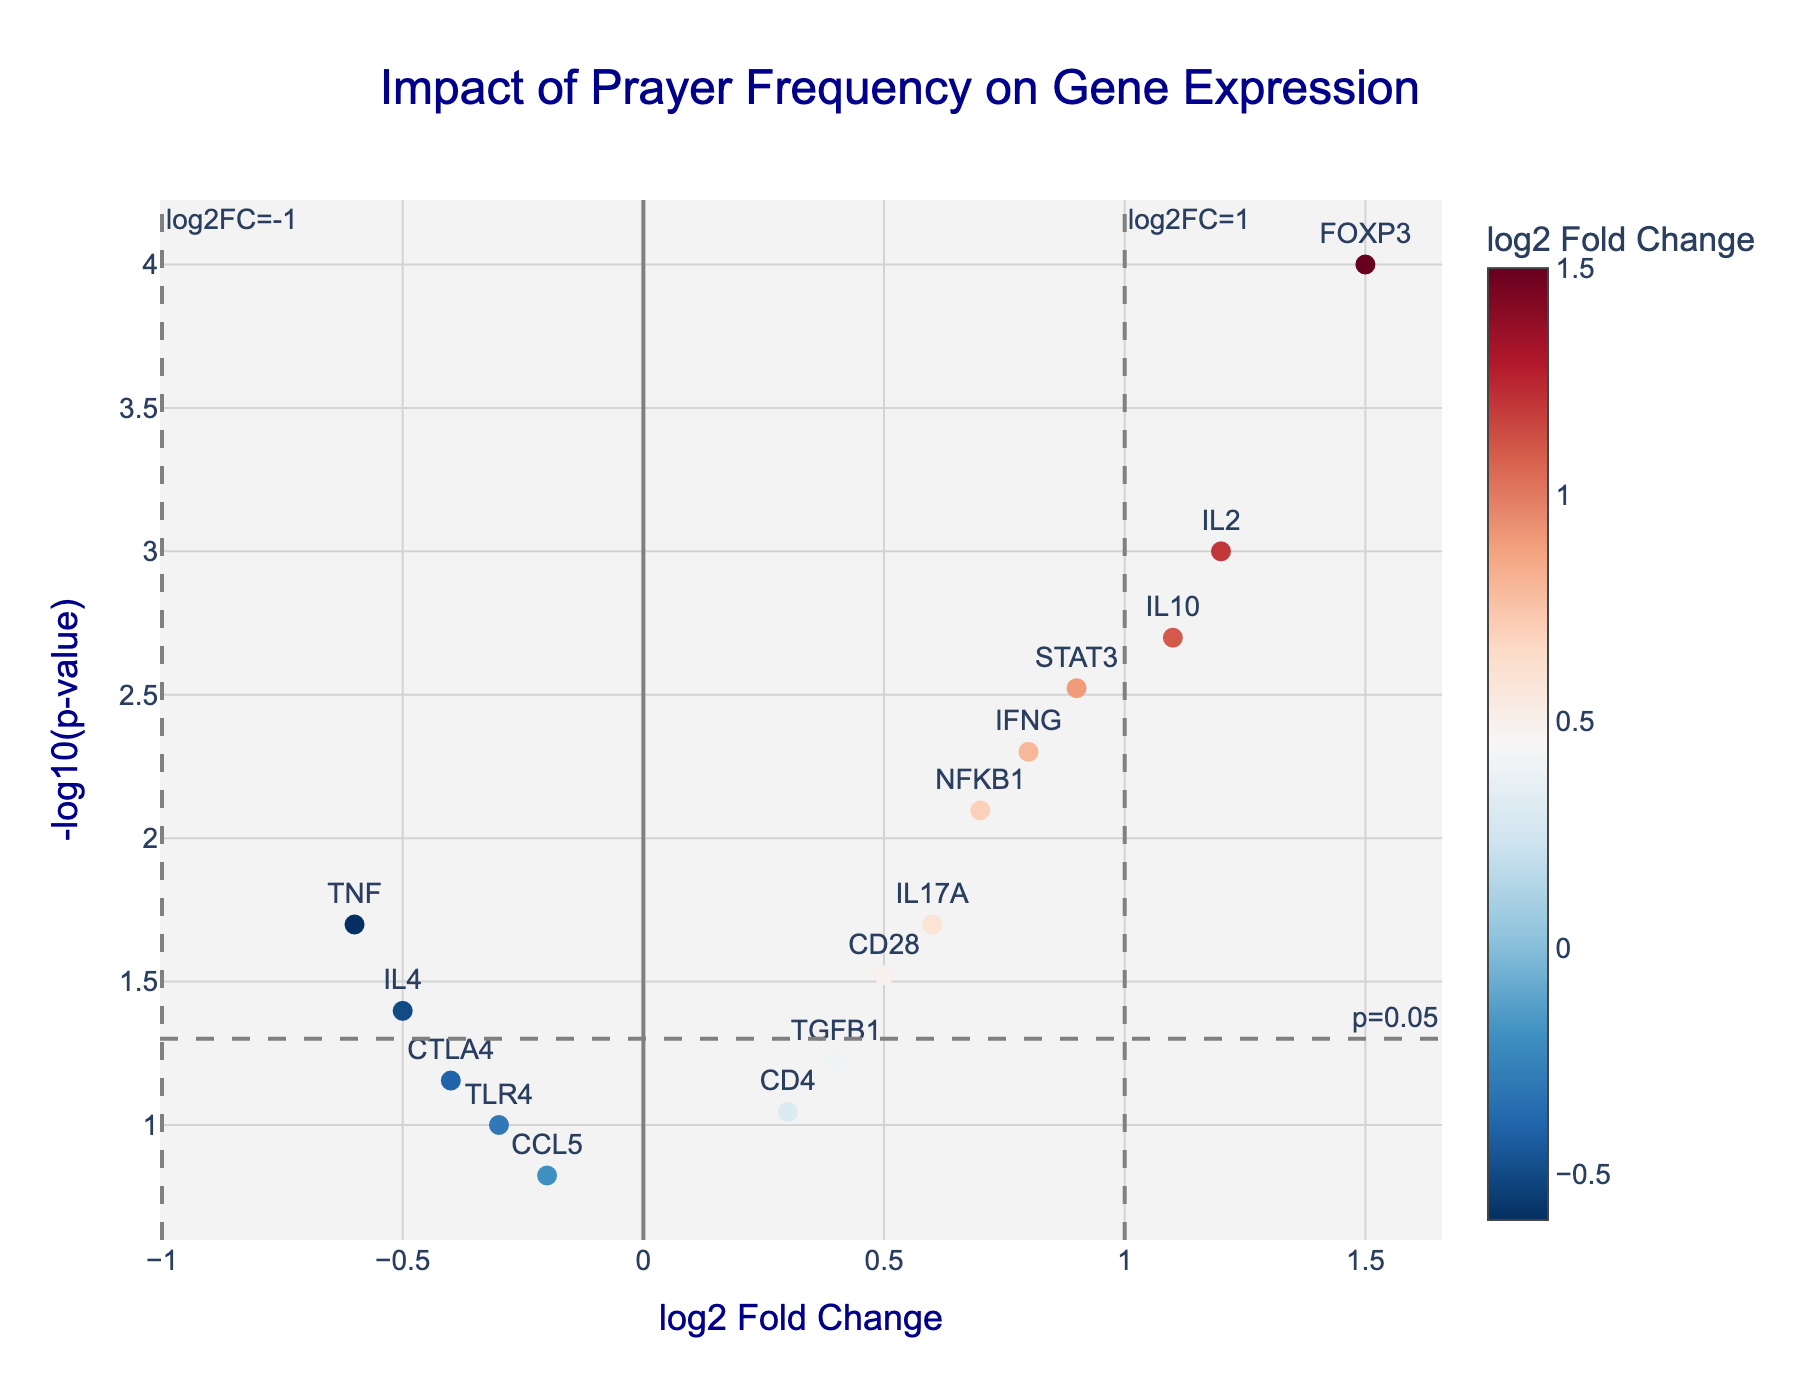Which gene has the highest log2 fold change? Find the data point with the highest log2 fold change on the x-axis. In the plot, FOXP3 has the highest log2 fold change.
Answer: FOXP3 Which gene has the lowest p-value? Look for the data point with the highest value on the y-axis, as p-values are transformed to -log10(p-value). The highest point on the y-axis corresponds to the lowest p-value.
Answer: FOXP3 How many genes have a log2 fold change greater than 1? Count the number of data points to the right of the vertical line at log2 fold change = 1. There are three such genes: IL2, FOXP3, and IL10.
Answer: 3 What is the log2 fold change and p-value of IFNG? Locate the data point labeled IFNG and read the x and y values from the axes. IFNG has a log2 fold change of 0.8 and a p-value of 0.005.
Answer: log2FC: 0.8, p-value: 0.005 Are there any genes with both a log2 fold change less than -1 and a p-value less than 0.05? Check the lower left quadrant where log2 fold change is less than -1 and the p-value is less than 0.05 (above the horizontal line at -log10(0.05)). There are no such genes.
Answer: No Which gene has the highest -log10(p-value) but a log2 fold change that is not statistically significant? Find the gene with the highest point on the y-axis that doesn't fall within the vertical lines at log2 fold change = -1 and 1. CD28 has the highest -log10(p-value) with a log2 fold change that is not statistically significant.
Answer: CD28 Which genes are close to a log2 fold change of 0 but have a p-value less than 0.05? Find the points near x=0 but above the horizontal line at -log10(0.05). Genes TNF, IL4, and IL17A have log2 fold changes close to 0 and p-values less than 0.05.
Answer: TNF, IL4, IL17A What is the color scale used to represent the log2 fold change values? The color scale is a gradient from blue to red. Higher log2 fold changes are displayed in red, while lower values are displayed in blue.
Answer: Blue to Red What is the significance threshold applied for p-values in this plot? Refer to the horizontal threshold line annotated with p=0.05.
Answer: p=0.05 